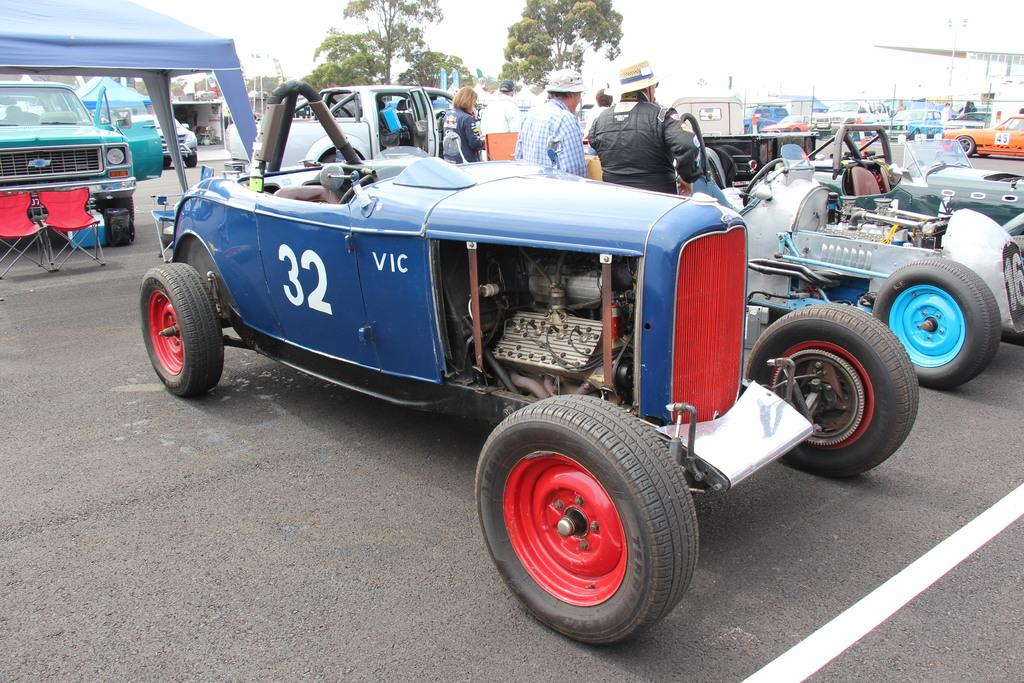What can be seen on the road in the image? There are vehicles on the road in the image. How can the vehicles be distinguished from one another? The vehicles are in different colors. Who or what else can be seen in the image? There are people visible in the image. What type of furniture is present in the image? There are red color chairs in the image. Is there any shelter or temporary structure in the image? Yes, there is a blue tent in the image. What type of natural elements are present in the image? Trees are present in the image. What type of sea creatures can be seen in the image? There are no sea creatures present in the image; it features vehicles, people, chairs, a tent, and trees. Can you provide a list of all the items mentioned in the image? It would be more appropriate to ask specific questions about the image rather than requesting a list of all items. However, based on the provided facts, the image contains vehicles, people, red chairs, a blue tent, and trees. 